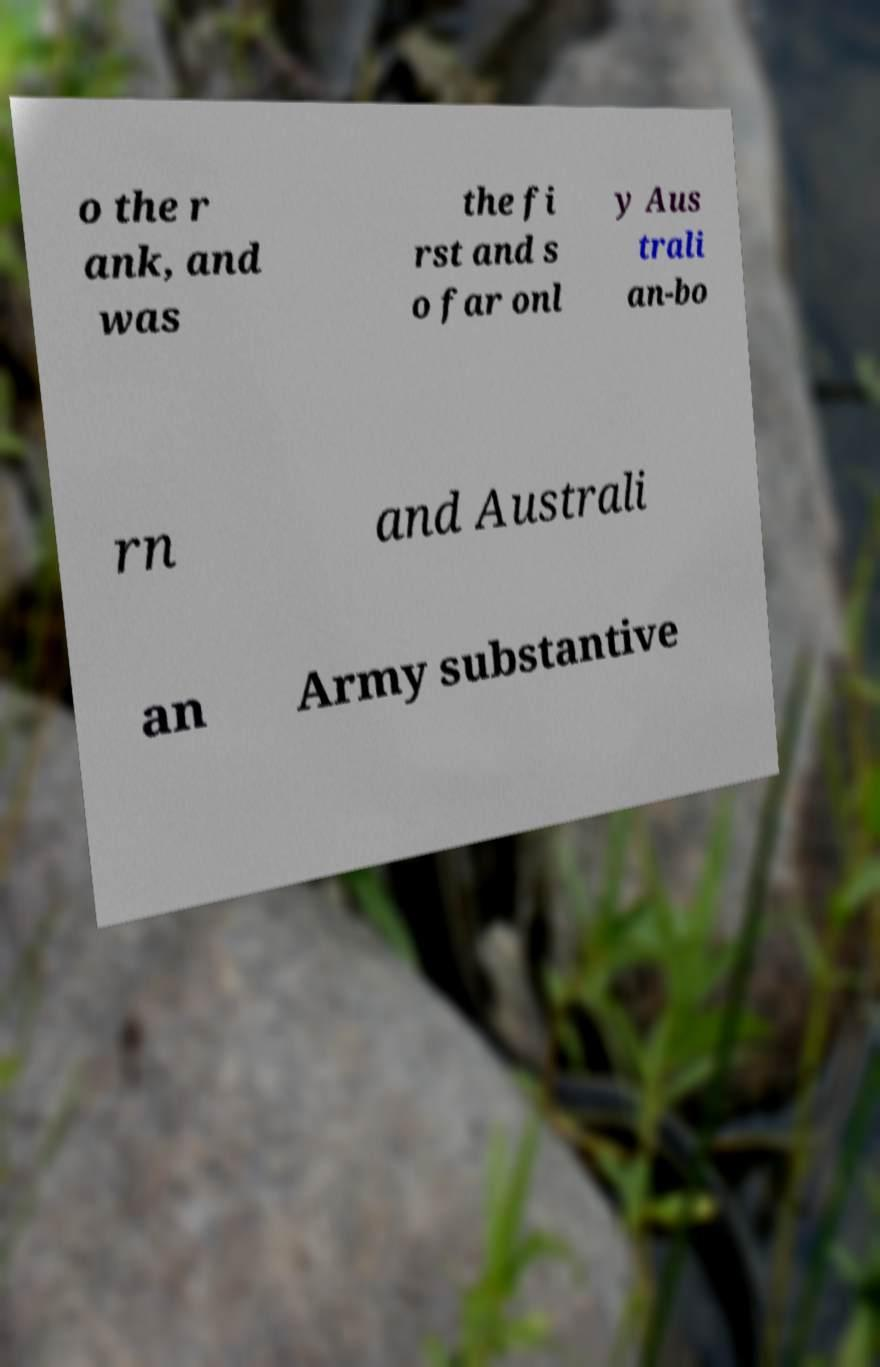Could you extract and type out the text from this image? o the r ank, and was the fi rst and s o far onl y Aus trali an-bo rn and Australi an Army substantive 